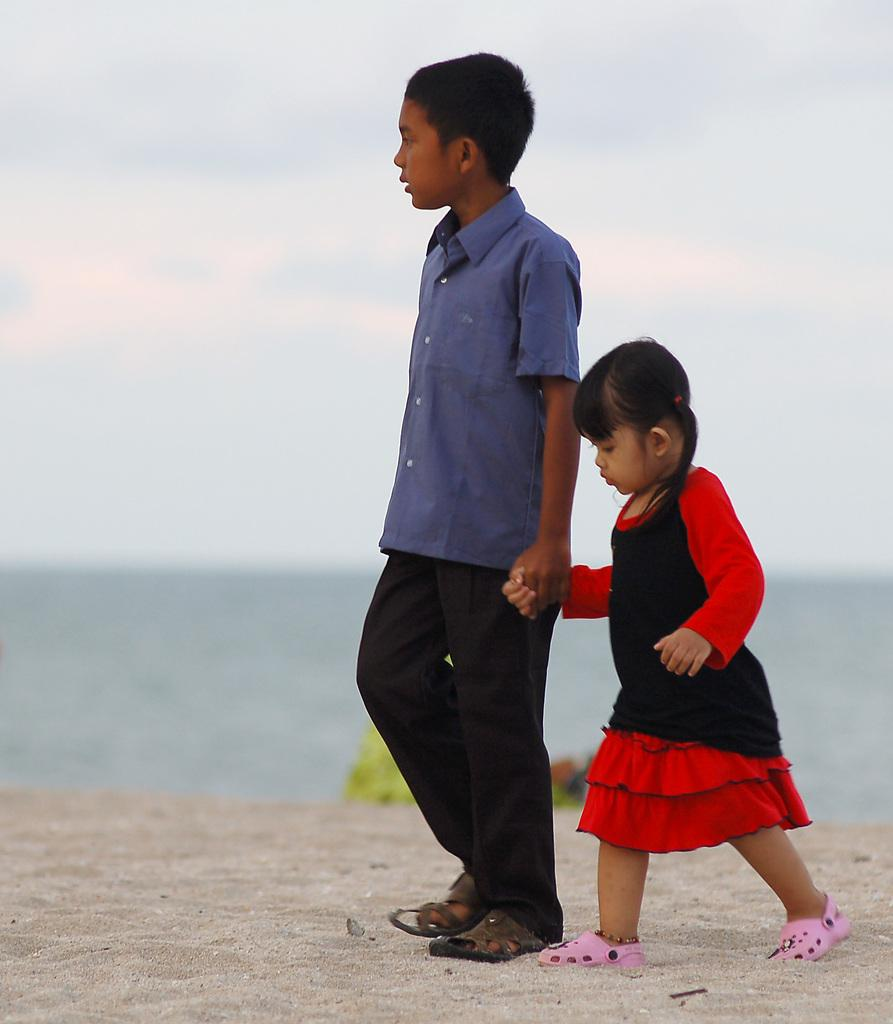How many kids are in the image? There are two kids in the image. What are the kids doing in the image? The kids are standing and holding each other. What can be seen in the background of the image? There is water visible in the background of the image. How many apples are on the ground in the image? There are no apples present in the image. What time of day is it in the image, given the presence of the night sky? The image does not depict a night sky, so it is not possible to determine the time of day based on the sky. 